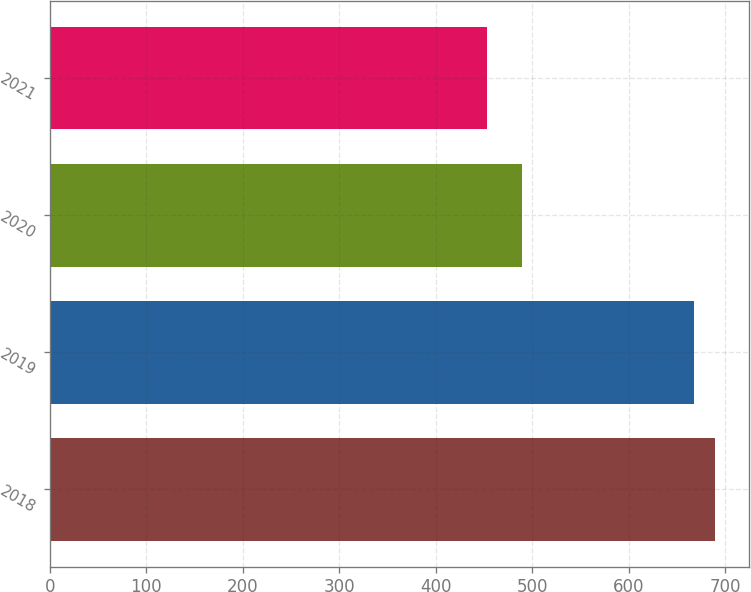Convert chart. <chart><loc_0><loc_0><loc_500><loc_500><bar_chart><fcel>2018<fcel>2019<fcel>2020<fcel>2021<nl><fcel>689.5<fcel>667<fcel>489<fcel>453<nl></chart> 